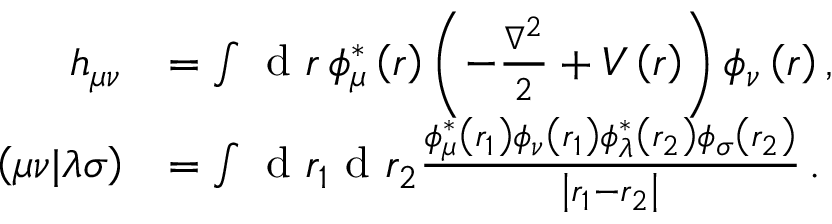Convert formula to latex. <formula><loc_0><loc_0><loc_500><loc_500>\begin{array} { r l } { h _ { \mu \nu } } & { = \int d r \, \phi _ { \mu } ^ { * } \left ( r \right ) \left ( - \frac { \nabla ^ { 2 } } { 2 } + V \left ( r \right ) \right ) \phi _ { \nu } \left ( r \right ) , } \\ { \left ( \mu \nu | \lambda \sigma \right ) } & { = \int d r _ { 1 } d r _ { 2 } \frac { \phi _ { \mu } ^ { * } \left ( r _ { 1 } \right ) \phi _ { \nu } \left ( r _ { 1 } \right ) \phi _ { \lambda } ^ { * } \left ( r _ { 2 } \right ) \phi _ { \sigma } \left ( r _ { 2 } \right ) } { \left | r _ { 1 } - r _ { 2 } \right | } \, . } \end{array}</formula> 